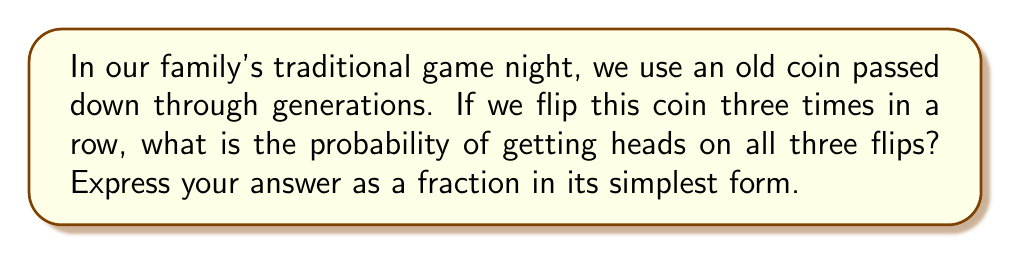Can you solve this math problem? Let's approach this step-by-step:

1) First, we need to understand that each coin flip is an independent event. The outcome of one flip does not affect the others.

2) For a fair coin, the probability of getting heads on a single flip is $\frac{1}{2}$.

3) We want the probability of getting heads three times in a row. This means we need heads on the first AND second AND third flip.

4) When we have independent events and we want all of them to occur, we multiply their individual probabilities.

5) So, our calculation will be:

   $$P(\text{3 Heads}) = P(\text{H}) \times P(\text{H}) \times P(\text{H})$$

   $$= \frac{1}{2} \times \frac{1}{2} \times \frac{1}{2}$$

   $$= \frac{1}{2^3} = \frac{1}{8}$$

6) Therefore, the probability of getting heads three times in a row is $\frac{1}{8}$.

This fraction is already in its simplest form, so no further reduction is necessary.
Answer: $\frac{1}{8}$ 